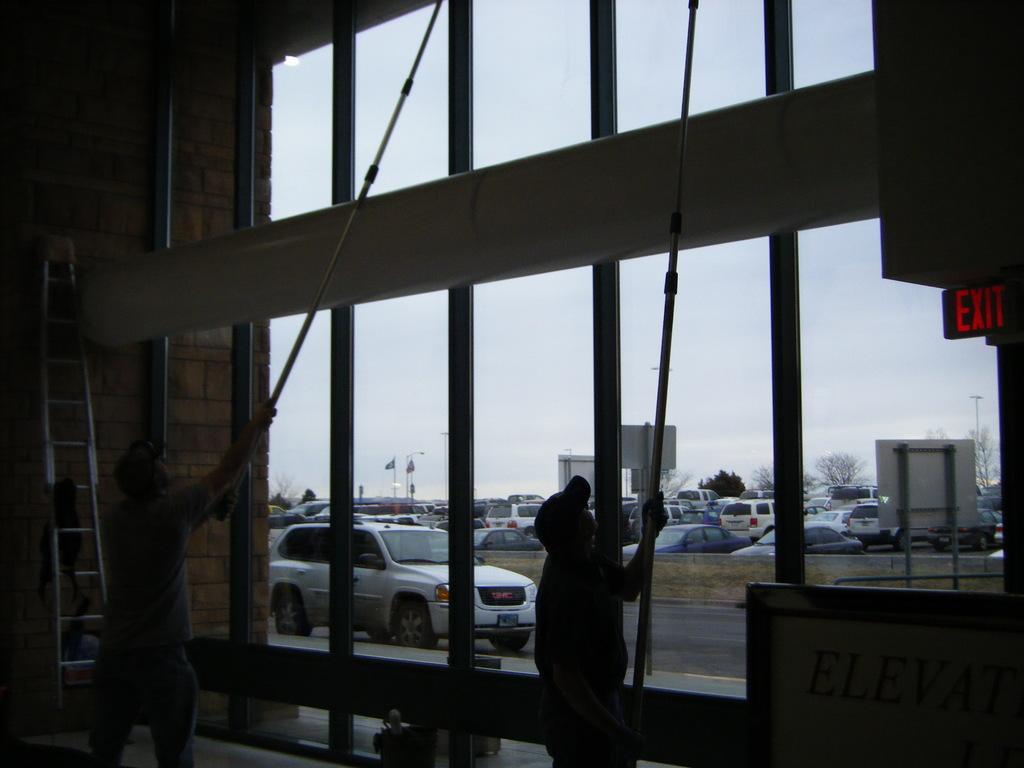Please provide a concise description of this image. In this image I can see two people cleaning the glass and on the left I can see the ladder, in this image I can many cars 